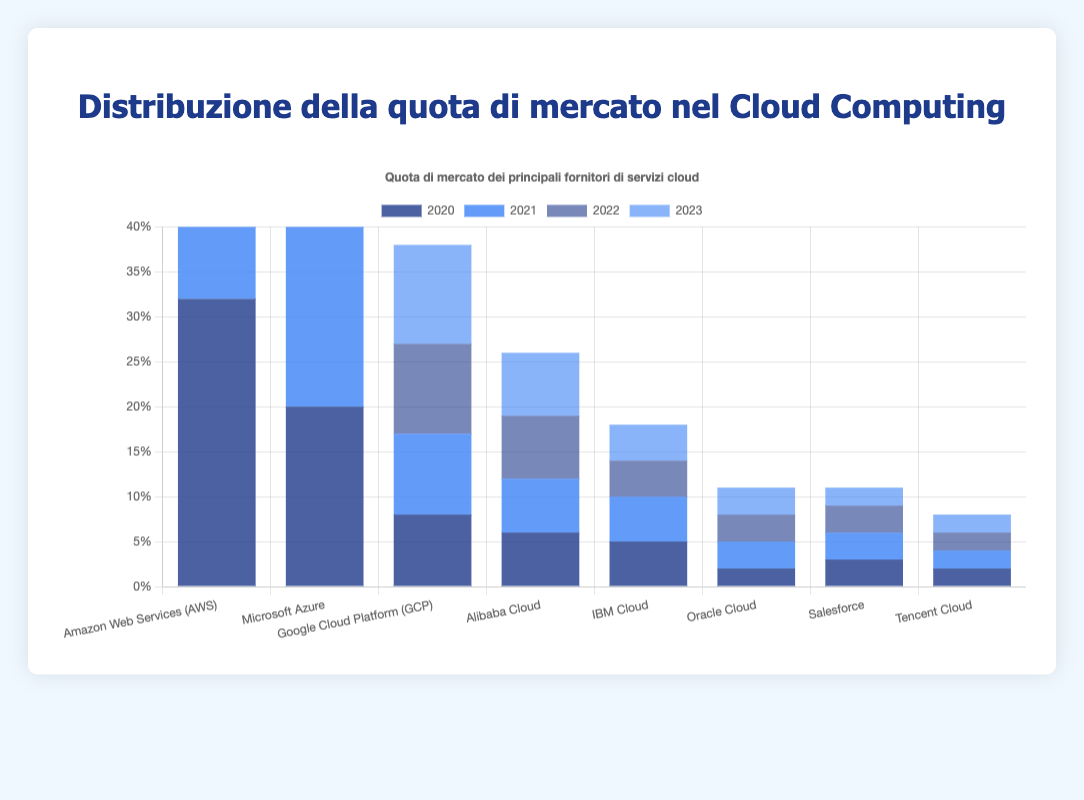What is the market share of AWS in 2023? From the chart, look for the height of the blue bar for AWS labeled 2023.
Answer: 33 Comparing Microsoft Azure and Google Cloud Platform (GCP) in 2022, which company has a higher market share? Look at the heights of the bars for Microsoft Azure and GCP for the year labeled 2022. Compare their heights visually.
Answer: Microsoft Azure Which company shows a steady increase in its market share from 2020 to 2023? Examine the trend of each company’s bars over the years. Identify which company’s bars increase in height every year from 2020 to 2023.
Answer: Microsoft Azure By how much did the market share of Alibaba Cloud increase from 2021 to 2023? Check the difference in the height of the bars for Alibaba Cloud between 2021 and 2023. Subtract the 2021 value from the 2023 value.
Answer: 1 What is the total market share of IBM Cloud over the four years displayed? Add up the heights of the bars for IBM Cloud for the years 2020, 2021, 2022, and 2023.
Answer: 18 Which year did AWS have its highest market share? What was that share? Compare the heights of AWS bars for all the years and identify the year with the tallest bar and note its value.
Answer: 2022, 34 Is there any company whose market share decreased in 2023 compared to 2022? Compare the heights of bars for each company between 2022 and 2023 and identify if any company’s bar is shorter in 2023.
Answer: Salesforce Which two companies had equal market share in 2023, and what was the value? Look at the heights of the bars for all companies in 2023 and identify the two companies with equal heights.
Answer: Alibaba Cloud and Salesforce, 7 